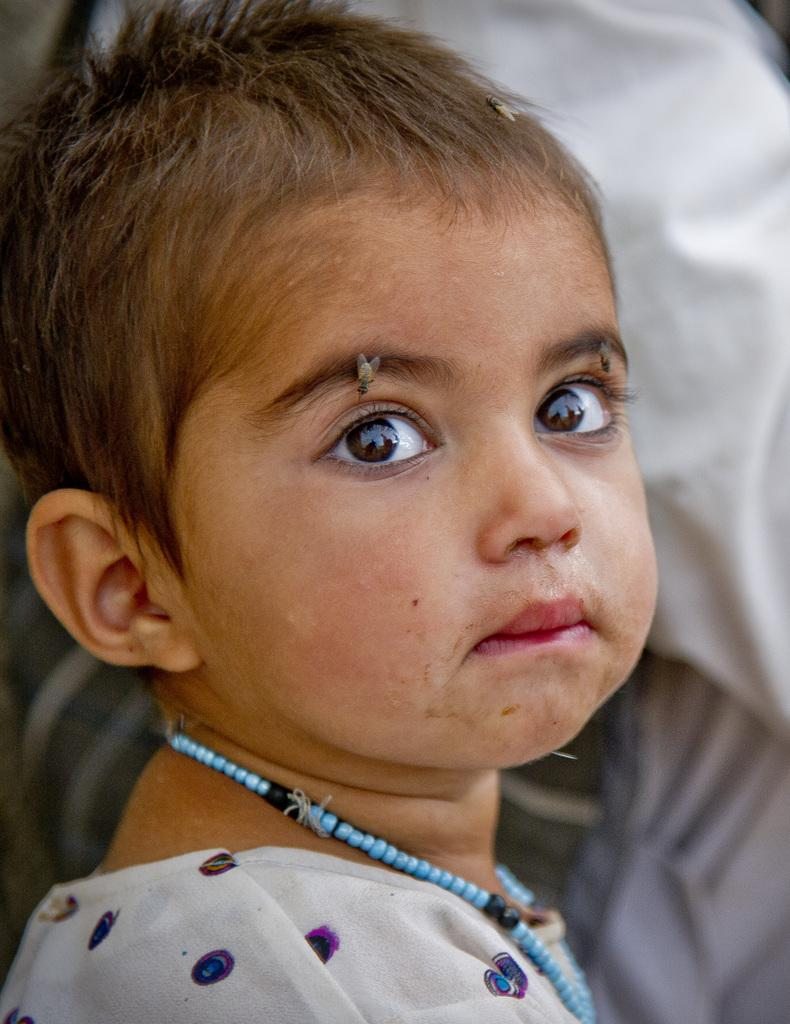What insects can be seen on the baby's face in the image? There are two flies on the baby's eyebrow and one fly on the baby's head in the image. What accessory is the baby wearing in the image? The baby is wearing a beaded necklace in the image. What can be seen in the background of the image? There is a white cloth in the background of the image. What type of basketball game is being played in the image? There is no basketball game present in the image. How many chickens are visible in the image? There are no chickens visible in the image. 